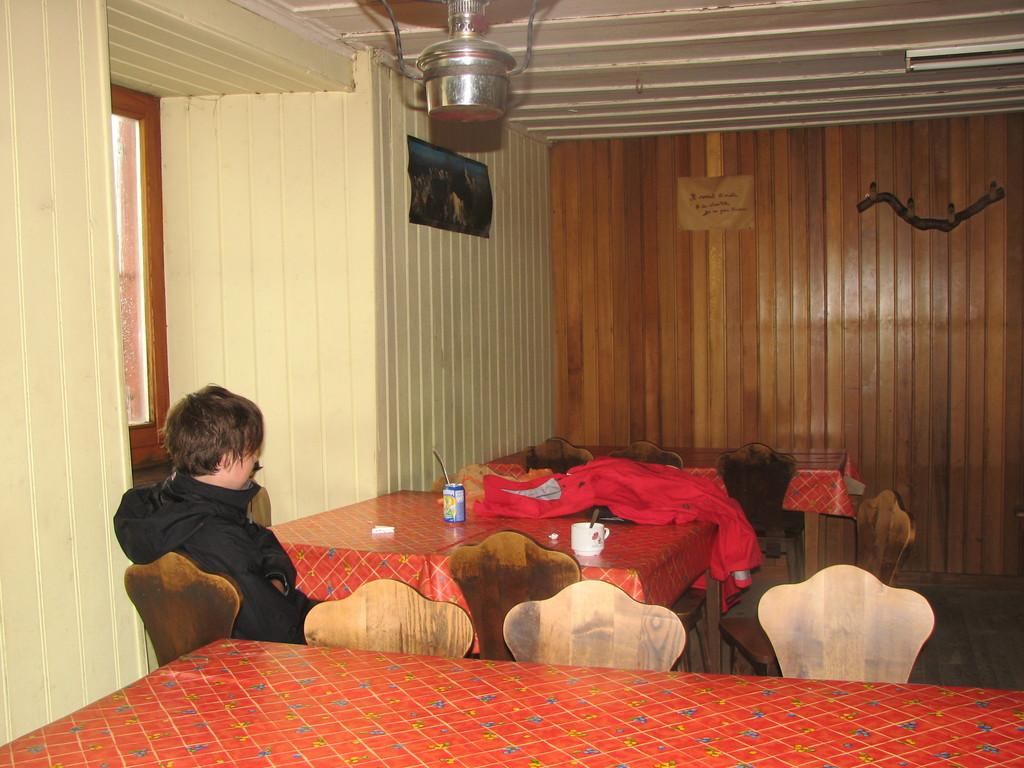What is the main subject of the image? There is a person sitting on a chair in the image. Where is the person located in relation to other objects? The person is in front of a table. Can you describe the surrounding environment in the image? There are additional tables and chairs visible in the image. What type of horn can be seen on the donkey in the image? There is no donkey or horn present in the image. What color is the curtain behind the person in the image? There is no curtain visible in the image. 